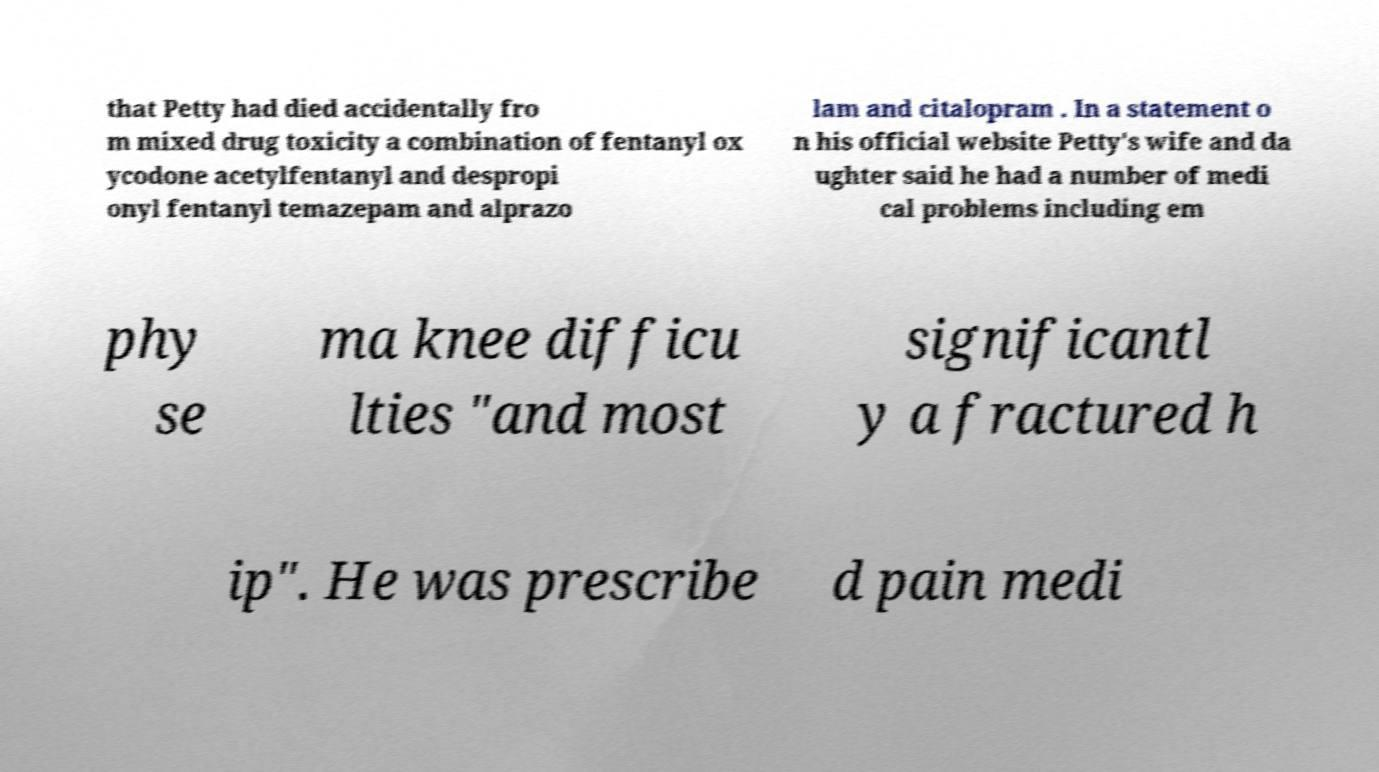I need the written content from this picture converted into text. Can you do that? that Petty had died accidentally fro m mixed drug toxicity a combination of fentanyl ox ycodone acetylfentanyl and despropi onyl fentanyl temazepam and alprazo lam and citalopram . In a statement o n his official website Petty's wife and da ughter said he had a number of medi cal problems including em phy se ma knee difficu lties "and most significantl y a fractured h ip". He was prescribe d pain medi 